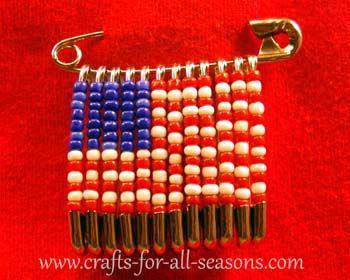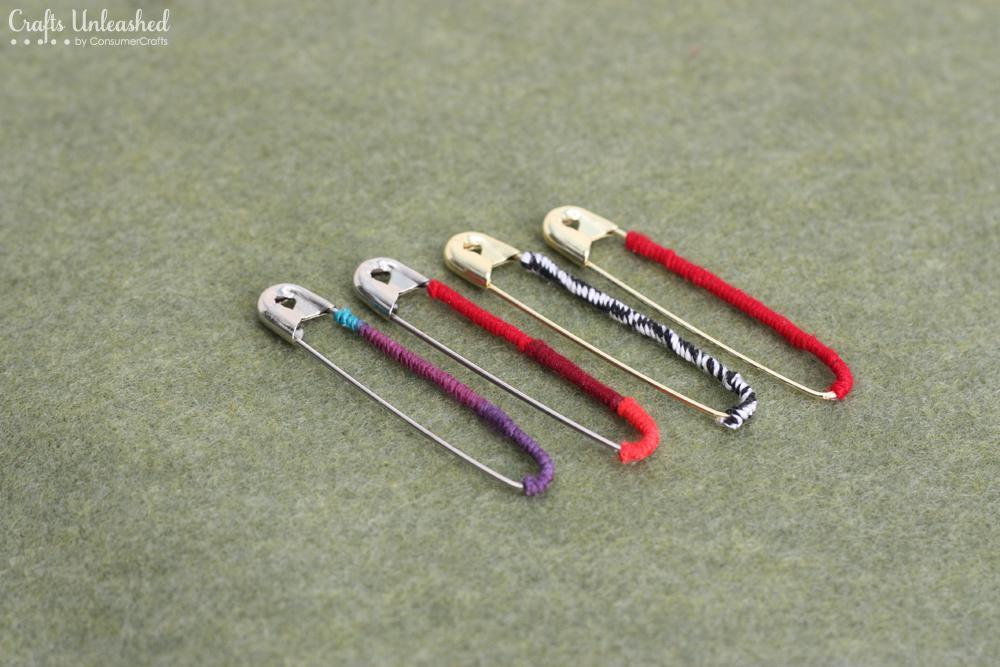The first image is the image on the left, the second image is the image on the right. Considering the images on both sides, is "An image includes a safety pin with a row of beaded pins suspended, which create a recognizable pattern." valid? Answer yes or no. Yes. The first image is the image on the left, the second image is the image on the right. For the images displayed, is the sentence "In one of the images there is a group of beaded safety pins that reveal a particular shape." factually correct? Answer yes or no. Yes. 